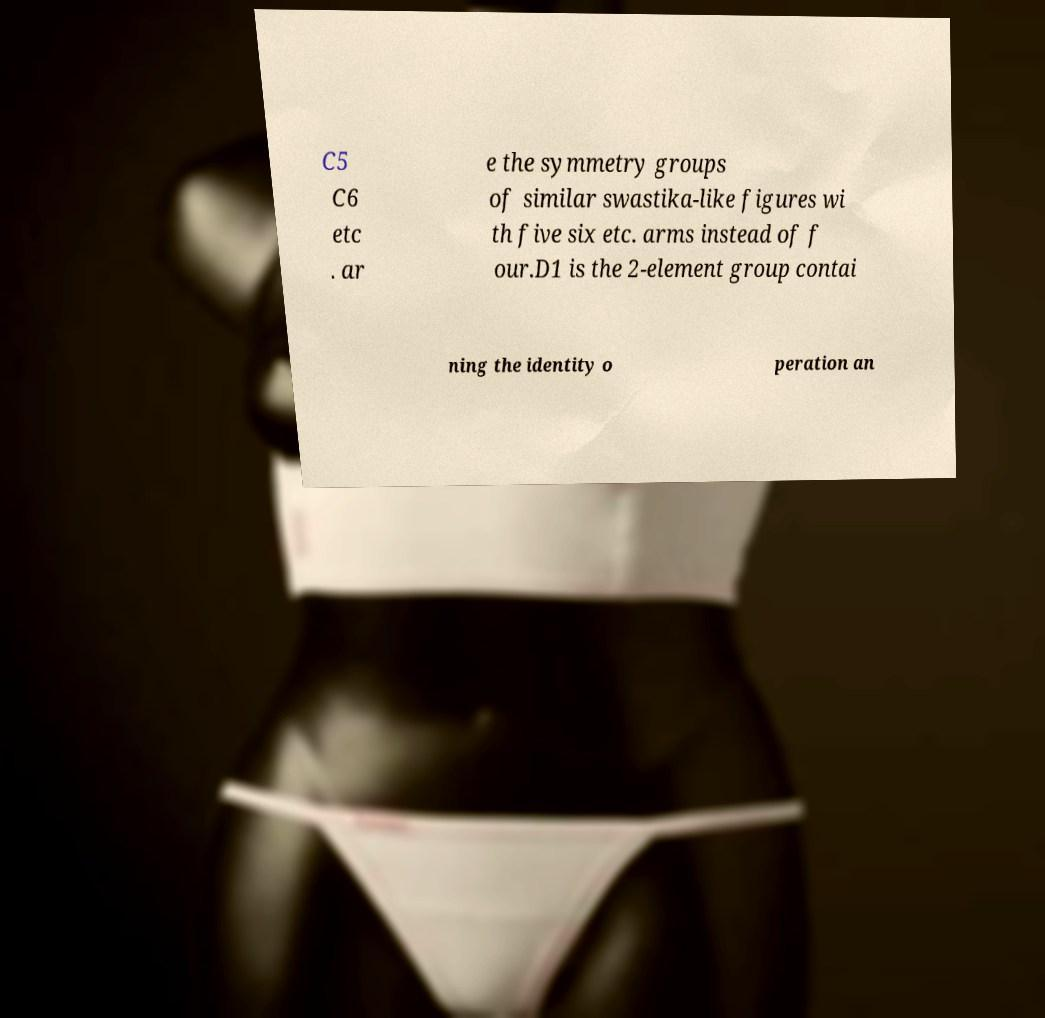Can you read and provide the text displayed in the image?This photo seems to have some interesting text. Can you extract and type it out for me? C5 C6 etc . ar e the symmetry groups of similar swastika-like figures wi th five six etc. arms instead of f our.D1 is the 2-element group contai ning the identity o peration an 